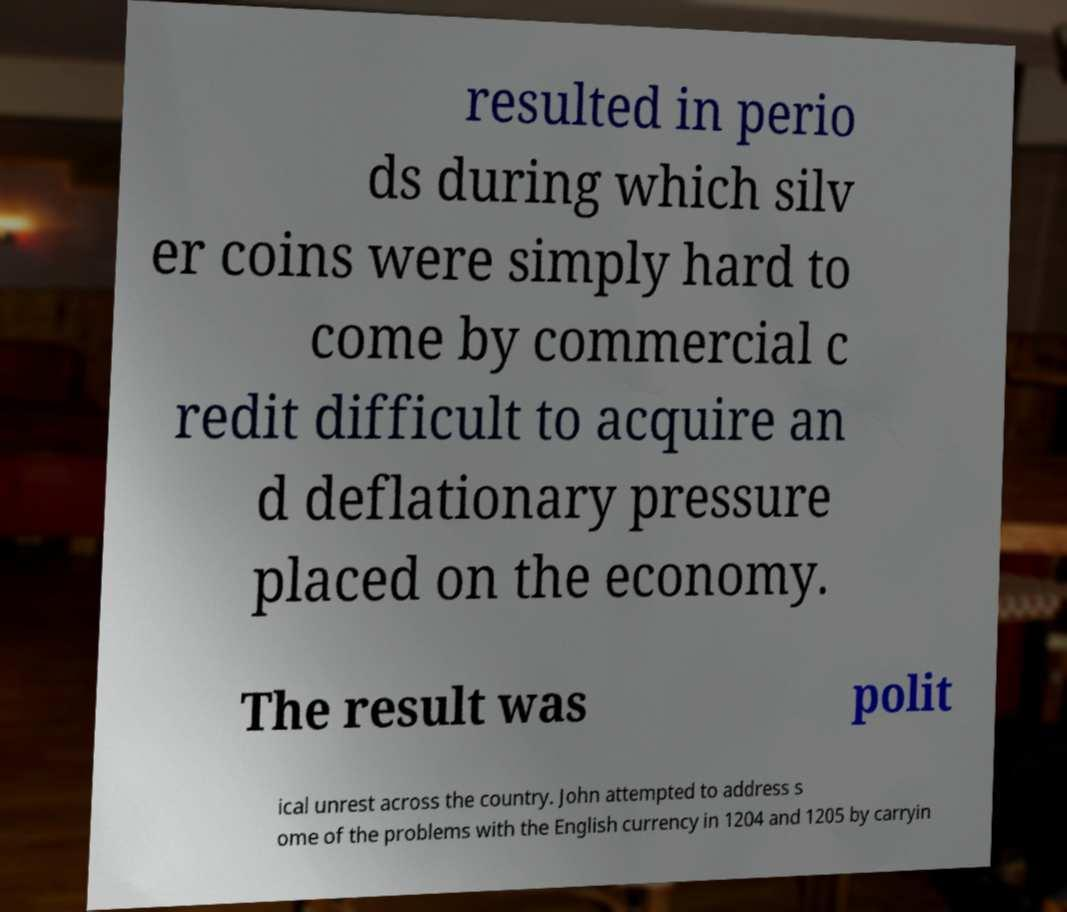For documentation purposes, I need the text within this image transcribed. Could you provide that? resulted in perio ds during which silv er coins were simply hard to come by commercial c redit difficult to acquire an d deflationary pressure placed on the economy. The result was polit ical unrest across the country. John attempted to address s ome of the problems with the English currency in 1204 and 1205 by carryin 